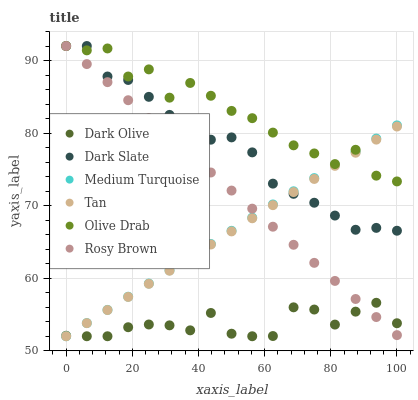Does Dark Olive have the minimum area under the curve?
Answer yes or no. Yes. Does Olive Drab have the maximum area under the curve?
Answer yes or no. Yes. Does Dark Slate have the minimum area under the curve?
Answer yes or no. No. Does Dark Slate have the maximum area under the curve?
Answer yes or no. No. Is Rosy Brown the smoothest?
Answer yes or no. Yes. Is Olive Drab the roughest?
Answer yes or no. Yes. Is Dark Olive the smoothest?
Answer yes or no. No. Is Dark Olive the roughest?
Answer yes or no. No. Does Dark Olive have the lowest value?
Answer yes or no. Yes. Does Dark Slate have the lowest value?
Answer yes or no. No. Does Olive Drab have the highest value?
Answer yes or no. Yes. Does Dark Olive have the highest value?
Answer yes or no. No. Is Dark Olive less than Dark Slate?
Answer yes or no. Yes. Is Dark Slate greater than Dark Olive?
Answer yes or no. Yes. Does Olive Drab intersect Rosy Brown?
Answer yes or no. Yes. Is Olive Drab less than Rosy Brown?
Answer yes or no. No. Is Olive Drab greater than Rosy Brown?
Answer yes or no. No. Does Dark Olive intersect Dark Slate?
Answer yes or no. No. 